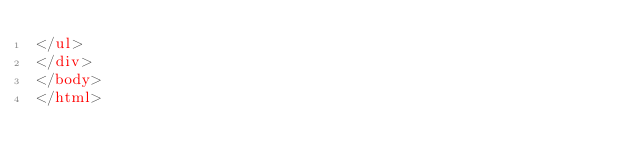<code> <loc_0><loc_0><loc_500><loc_500><_HTML_></ul>
</div>
</body>
</html>
</code> 